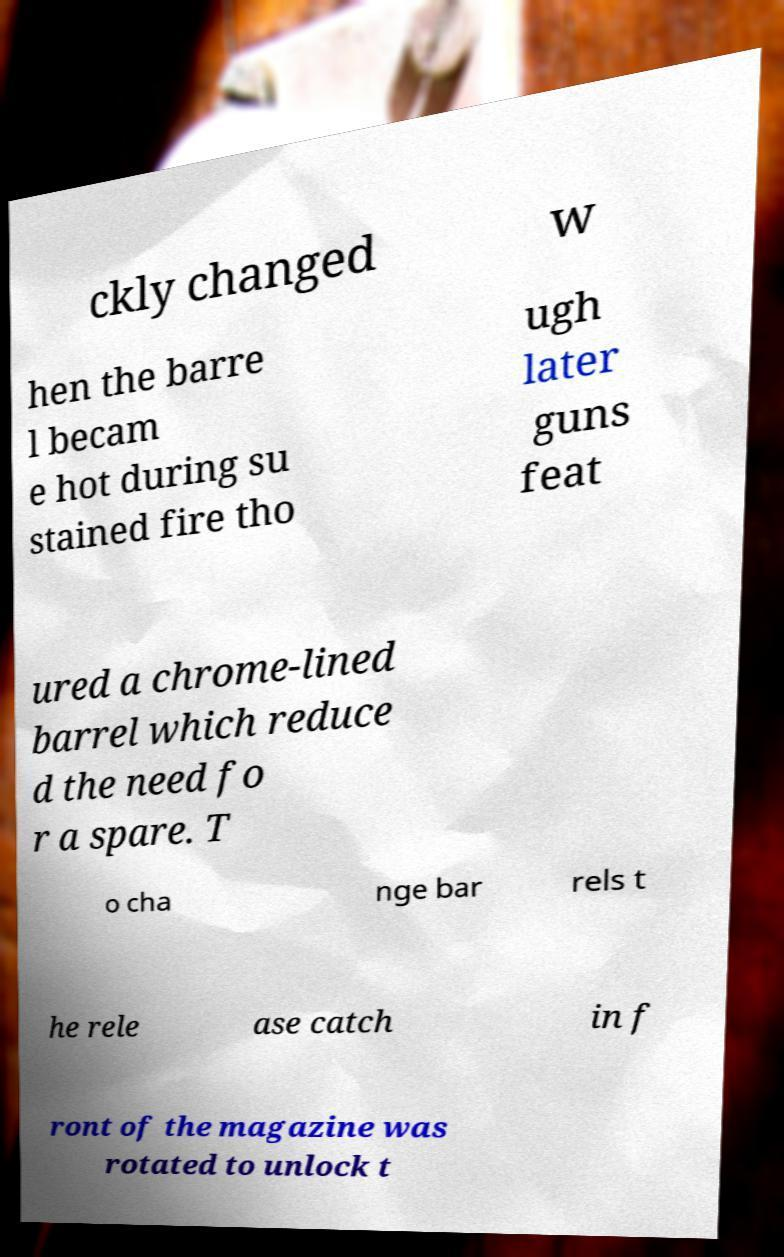Please read and relay the text visible in this image. What does it say? ckly changed w hen the barre l becam e hot during su stained fire tho ugh later guns feat ured a chrome-lined barrel which reduce d the need fo r a spare. T o cha nge bar rels t he rele ase catch in f ront of the magazine was rotated to unlock t 